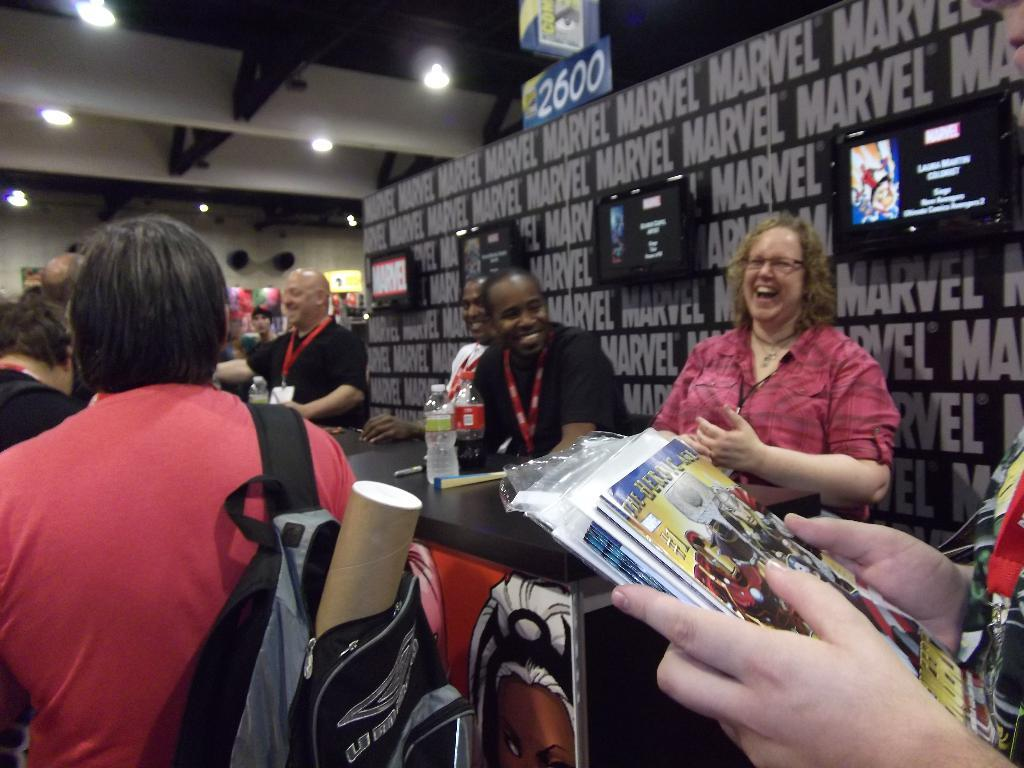<image>
Relay a brief, clear account of the picture shown. People sitting at a table with a Marvel wall behind them. 